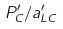Convert formula to latex. <formula><loc_0><loc_0><loc_500><loc_500>P _ { C } ^ { \prime } / a _ { L C } ^ { \prime }</formula> 